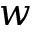<formula> <loc_0><loc_0><loc_500><loc_500>w</formula> 